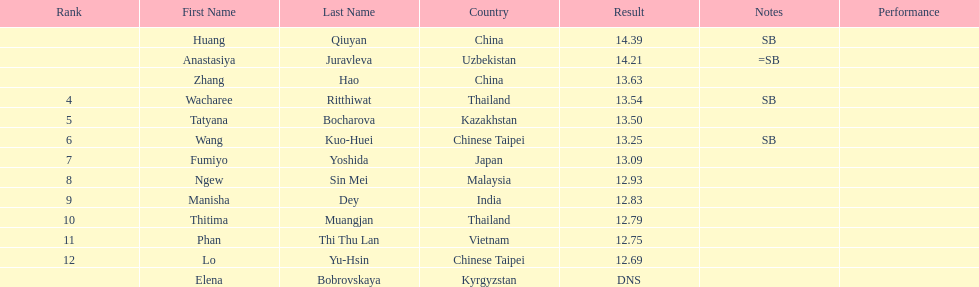What is the number of different nationalities represented by the top 5 athletes? 4. 